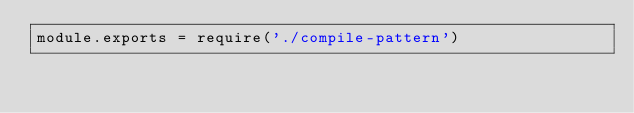<code> <loc_0><loc_0><loc_500><loc_500><_JavaScript_>module.exports = require('./compile-pattern')
</code> 